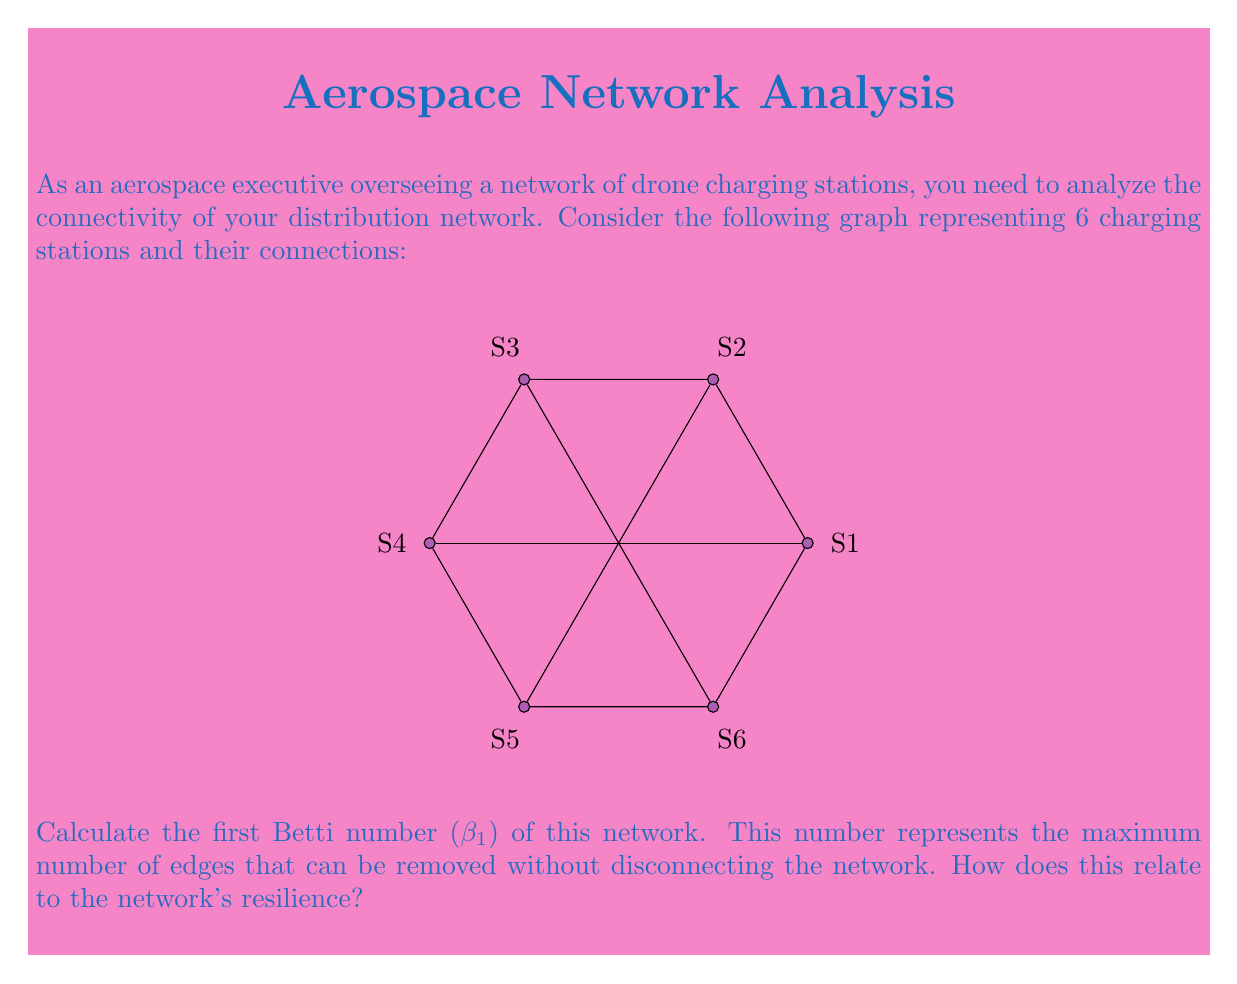Can you solve this math problem? To calculate the first Betti number ($$\beta_1$$) of this network, we'll follow these steps:

1) First, recall the formula for the first Betti number:
   $$\beta_1 = E - V + 1$$
   Where E is the number of edges and V is the number of vertices.

2) Count the number of vertices (V):
   There are 6 charging stations, so V = 6.

3) Count the number of edges (E):
   There are 9 connections between the stations, so E = 9.

4) Apply the formula:
   $$\beta_1 = E - V + 1 = 9 - 6 + 1 = 4$$

5) Interpretation:
   The first Betti number of 4 means that we can remove up to 4 edges without disconnecting the network. This indicates a high level of redundancy and resilience in the charging station network.

   In the context of drone charging stations, this means:
   a) The network can maintain connectivity even if up to 4 connections fail.
   b) There are multiple paths between stations, allowing for efficient routing and load balancing.
   c) The network has a good balance between connectivity and cost-efficiency, as it's not fully connected (which would require 15 edges) but still highly resilient.
Answer: $$\beta_1 = 4$$ 